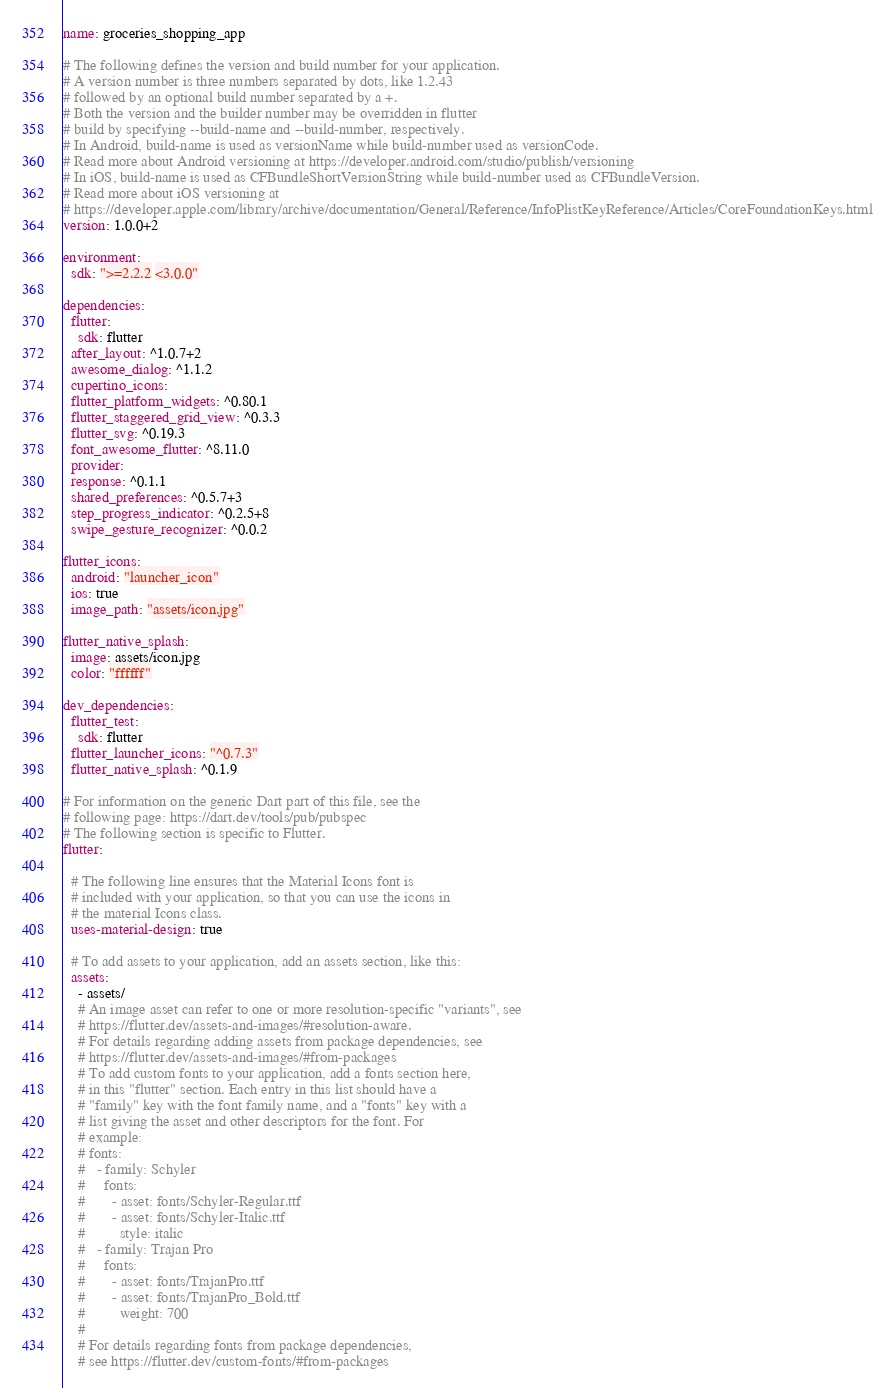Convert code to text. <code><loc_0><loc_0><loc_500><loc_500><_YAML_>name: groceries_shopping_app

# The following defines the version and build number for your application.
# A version number is three numbers separated by dots, like 1.2.43
# followed by an optional build number separated by a +.
# Both the version and the builder number may be overridden in flutter
# build by specifying --build-name and --build-number, respectively.
# In Android, build-name is used as versionName while build-number used as versionCode.
# Read more about Android versioning at https://developer.android.com/studio/publish/versioning
# In iOS, build-name is used as CFBundleShortVersionString while build-number used as CFBundleVersion.
# Read more about iOS versioning at
# https://developer.apple.com/library/archive/documentation/General/Reference/InfoPlistKeyReference/Articles/CoreFoundationKeys.html
version: 1.0.0+2

environment:
  sdk: ">=2.2.2 <3.0.0"

dependencies:
  flutter:
    sdk: flutter
  after_layout: ^1.0.7+2
  awesome_dialog: ^1.1.2
  cupertino_icons: 
  flutter_platform_widgets: ^0.80.1
  flutter_staggered_grid_view: ^0.3.3
  flutter_svg: ^0.19.3
  font_awesome_flutter: ^8.11.0
  provider: 
  response: ^0.1.1
  shared_preferences: ^0.5.7+3
  step_progress_indicator: ^0.2.5+8
  swipe_gesture_recognizer: ^0.0.2

flutter_icons:
  android: "launcher_icon"
  ios: true
  image_path: "assets/icon.jpg"

flutter_native_splash:
  image: assets/icon.jpg
  color: "ffffff"

dev_dependencies:
  flutter_test:
    sdk: flutter
  flutter_launcher_icons: "^0.7.3"
  flutter_native_splash: ^0.1.9

# For information on the generic Dart part of this file, see the
# following page: https://dart.dev/tools/pub/pubspec
# The following section is specific to Flutter.
flutter:

  # The following line ensures that the Material Icons font is
  # included with your application, so that you can use the icons in
  # the material Icons class.
  uses-material-design: true

  # To add assets to your application, add an assets section, like this:
  assets:
    - assets/
    # An image asset can refer to one or more resolution-specific "variants", see
    # https://flutter.dev/assets-and-images/#resolution-aware.
    # For details regarding adding assets from package dependencies, see
    # https://flutter.dev/assets-and-images/#from-packages
    # To add custom fonts to your application, add a fonts section here,
    # in this "flutter" section. Each entry in this list should have a
    # "family" key with the font family name, and a "fonts" key with a
    # list giving the asset and other descriptors for the font. For
    # example:
    # fonts:
    #   - family: Schyler
    #     fonts:
    #       - asset: fonts/Schyler-Regular.ttf
    #       - asset: fonts/Schyler-Italic.ttf
    #         style: italic
    #   - family: Trajan Pro
    #     fonts:
    #       - asset: fonts/TrajanPro.ttf
    #       - asset: fonts/TrajanPro_Bold.ttf
    #         weight: 700
    #
    # For details regarding fonts from package dependencies,
    # see https://flutter.dev/custom-fonts/#from-packages
</code> 